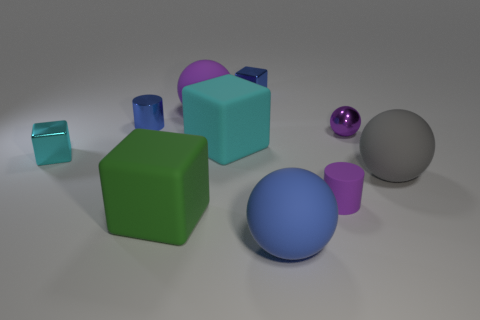Do these objects share any common characteristics? Although the objects differ in shape and color, they all have a matte finish and are clearly defined against the neutral background. 